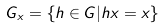Convert formula to latex. <formula><loc_0><loc_0><loc_500><loc_500>G _ { x } = \{ h \in G | h x = x \}</formula> 